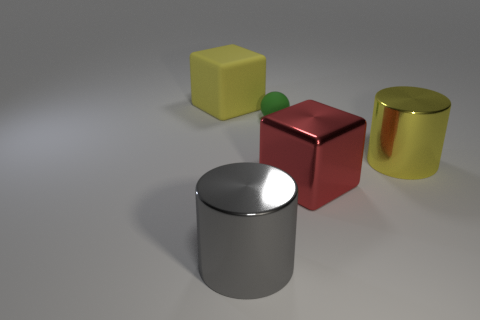Add 3 big brown cylinders. How many objects exist? 8 Subtract all red cubes. How many cubes are left? 1 Subtract all spheres. How many objects are left? 4 Subtract all yellow cylinders. Subtract all gray shiny cylinders. How many objects are left? 3 Add 5 metal objects. How many metal objects are left? 8 Add 3 large red rubber blocks. How many large red rubber blocks exist? 3 Subtract 0 purple cubes. How many objects are left? 5 Subtract all gray cylinders. Subtract all brown balls. How many cylinders are left? 1 